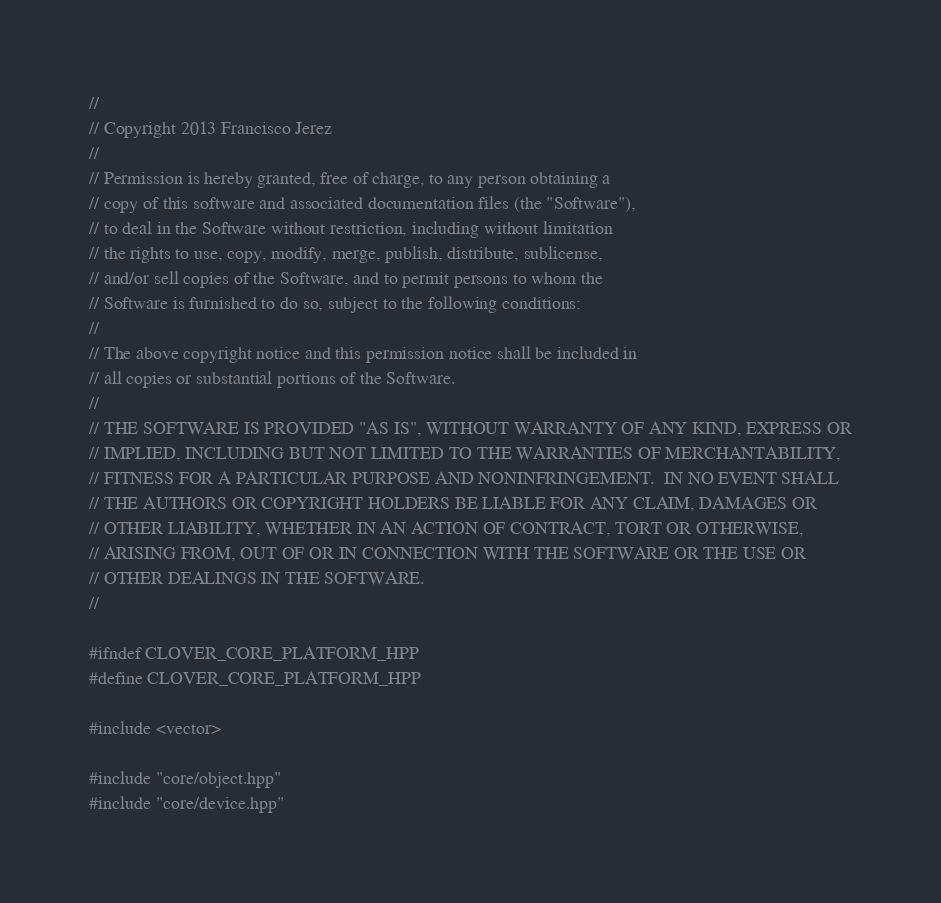Convert code to text. <code><loc_0><loc_0><loc_500><loc_500><_C++_>//
// Copyright 2013 Francisco Jerez
//
// Permission is hereby granted, free of charge, to any person obtaining a
// copy of this software and associated documentation files (the "Software"),
// to deal in the Software without restriction, including without limitation
// the rights to use, copy, modify, merge, publish, distribute, sublicense,
// and/or sell copies of the Software, and to permit persons to whom the
// Software is furnished to do so, subject to the following conditions:
//
// The above copyright notice and this permission notice shall be included in
// all copies or substantial portions of the Software.
//
// THE SOFTWARE IS PROVIDED "AS IS", WITHOUT WARRANTY OF ANY KIND, EXPRESS OR
// IMPLIED, INCLUDING BUT NOT LIMITED TO THE WARRANTIES OF MERCHANTABILITY,
// FITNESS FOR A PARTICULAR PURPOSE AND NONINFRINGEMENT.  IN NO EVENT SHALL
// THE AUTHORS OR COPYRIGHT HOLDERS BE LIABLE FOR ANY CLAIM, DAMAGES OR
// OTHER LIABILITY, WHETHER IN AN ACTION OF CONTRACT, TORT OR OTHERWISE,
// ARISING FROM, OUT OF OR IN CONNECTION WITH THE SOFTWARE OR THE USE OR
// OTHER DEALINGS IN THE SOFTWARE.
//

#ifndef CLOVER_CORE_PLATFORM_HPP
#define CLOVER_CORE_PLATFORM_HPP

#include <vector>

#include "core/object.hpp"
#include "core/device.hpp"</code> 